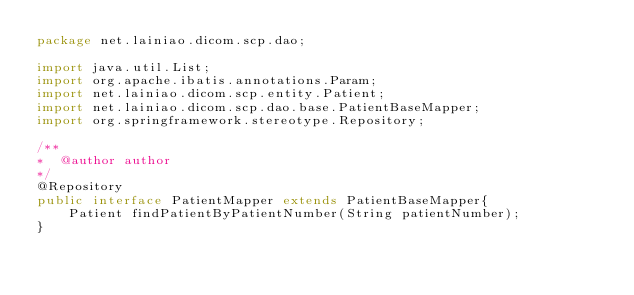<code> <loc_0><loc_0><loc_500><loc_500><_Java_>package net.lainiao.dicom.scp.dao;

import java.util.List;
import org.apache.ibatis.annotations.Param;
import net.lainiao.dicom.scp.entity.Patient;
import net.lainiao.dicom.scp.dao.base.PatientBaseMapper;
import org.springframework.stereotype.Repository;

/**
*  @author author
*/
@Repository
public interface PatientMapper extends PatientBaseMapper{
    Patient findPatientByPatientNumber(String patientNumber);
}</code> 